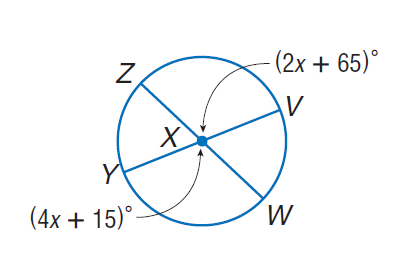Answer the mathemtical geometry problem and directly provide the correct option letter.
Question: Find m \angle Z X Y.
Choices: A: 25 B: 65 C: 115 D: 180 B 